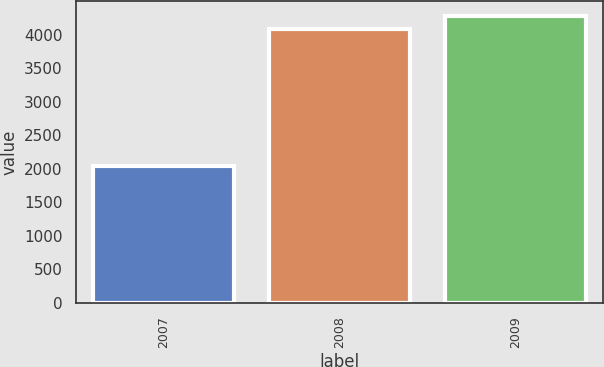Convert chart. <chart><loc_0><loc_0><loc_500><loc_500><bar_chart><fcel>2007<fcel>2008<fcel>2009<nl><fcel>2040<fcel>4080<fcel>4284<nl></chart> 